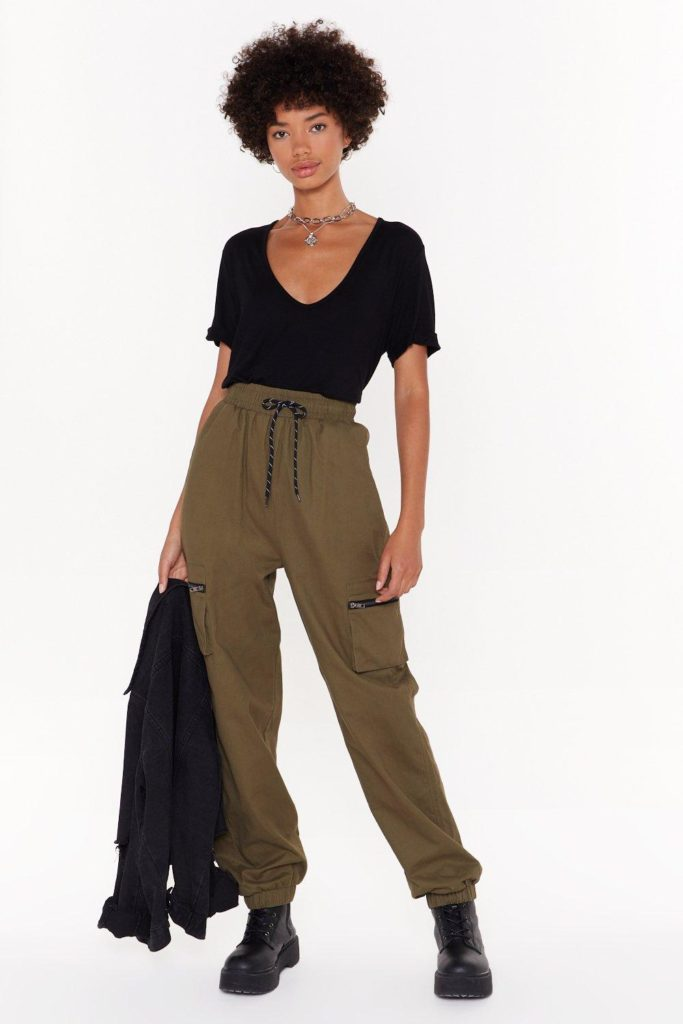Imagine this photograph is part of an art exhibition. What could be the theme of the exhibition? The image could be part of an art exhibition themed around 'Modern Nomads: The Fusion of Urban and Wilderness'. The exhibition would explore the intersection between contemporary urban life and the elements of rugged wilderness. Through fashion, posture, and expression, the exhibition would portray the balancing act between modern aesthetics and the timeless allure of adventure and exploration. Each piece would highlight how today's nomads seamlessly blend practicality with style, embodying a spirit of freedom and resilience. What kind of other exhibits would complement this photograph in such an exhibition? Other exhibits could include photography and art showcasing urban explorers in natural environments, dramatic portraits of individuals in mixed landscapes that feature elements of both city and wilderness, and installations that incorporate materials like reclaimed wood, metals, and modern textiles. Interactive displays might allow visitors to feel the textures of the materials used in the portrayed outfits, and immersive virtual reality experiences could simulate the environments depicted in the artworks. The exhibition could also include short films and documentaries focused on personal stories of modern adventurers and urban explorers, providing a rich, multifaceted experience. 